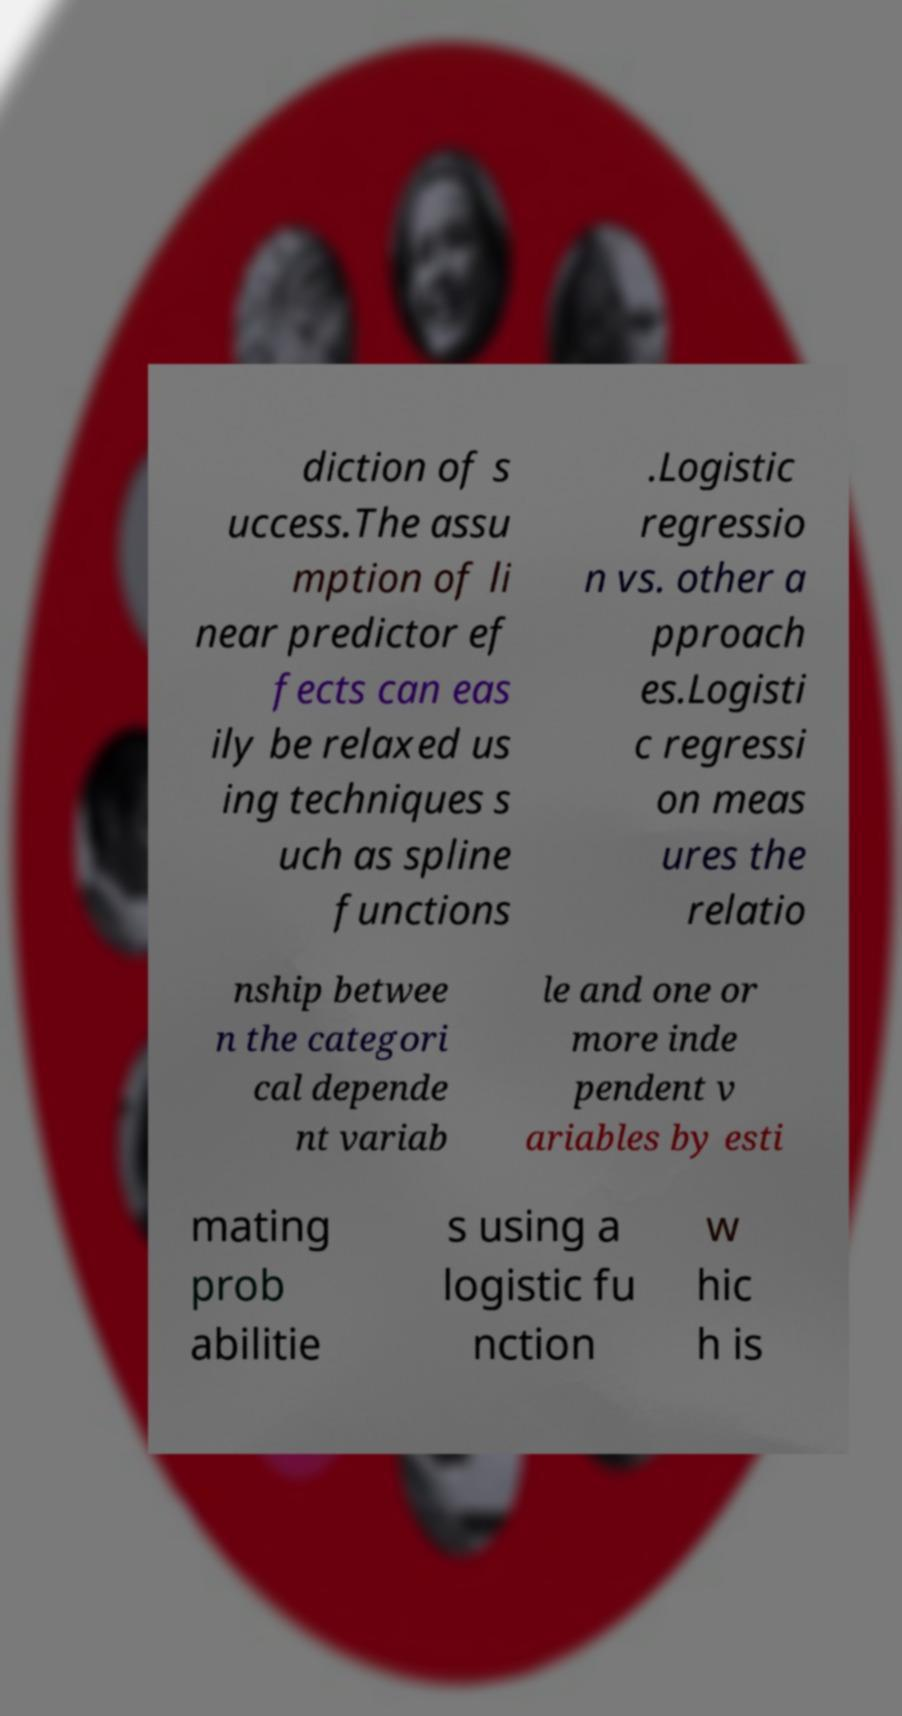I need the written content from this picture converted into text. Can you do that? diction of s uccess.The assu mption of li near predictor ef fects can eas ily be relaxed us ing techniques s uch as spline functions .Logistic regressio n vs. other a pproach es.Logisti c regressi on meas ures the relatio nship betwee n the categori cal depende nt variab le and one or more inde pendent v ariables by esti mating prob abilitie s using a logistic fu nction w hic h is 